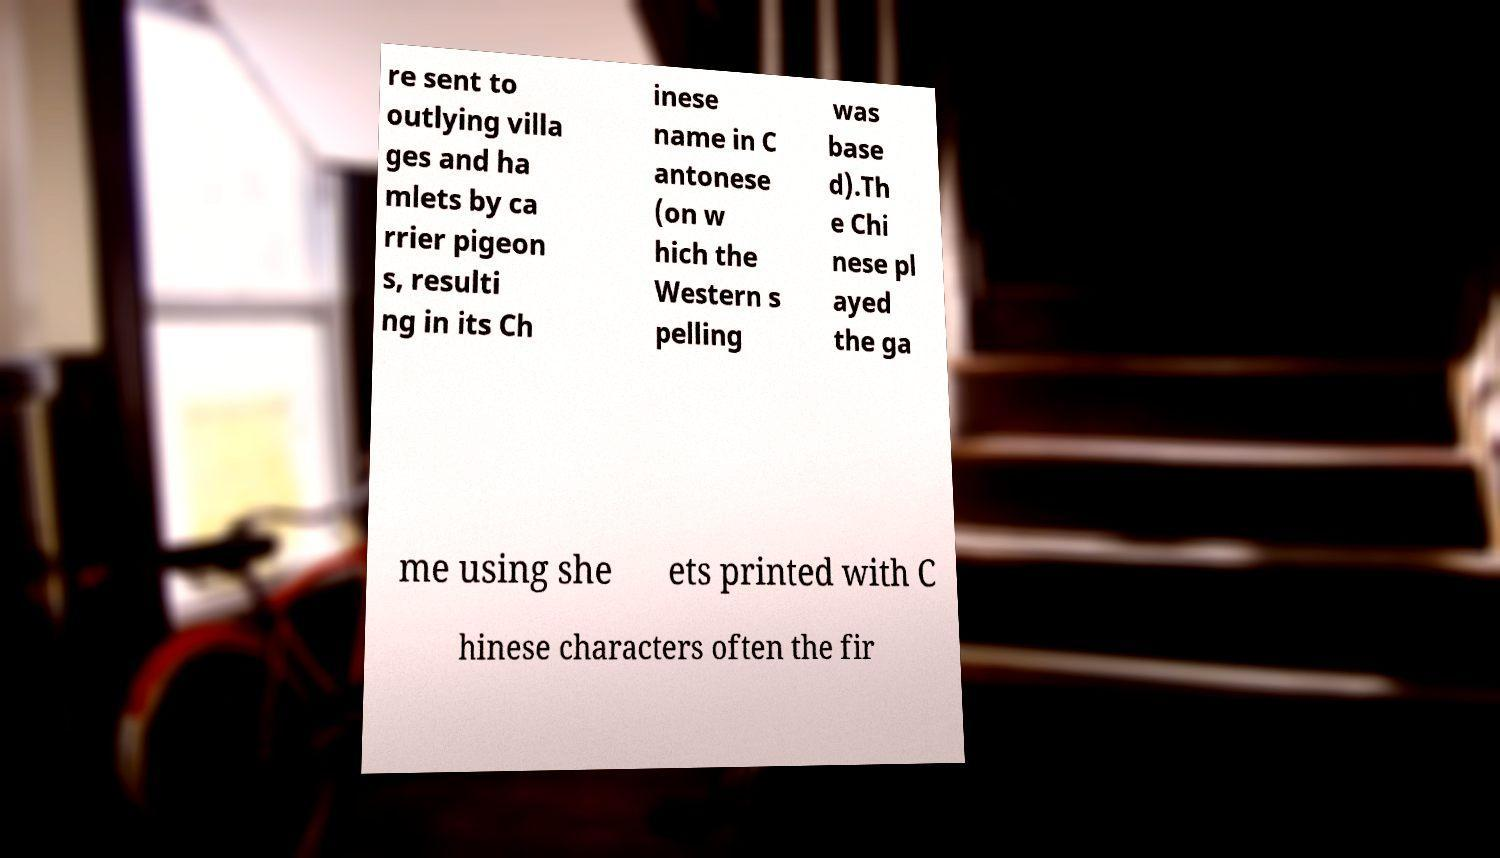Could you extract and type out the text from this image? re sent to outlying villa ges and ha mlets by ca rrier pigeon s, resulti ng in its Ch inese name in C antonese (on w hich the Western s pelling was base d).Th e Chi nese pl ayed the ga me using she ets printed with C hinese characters often the fir 